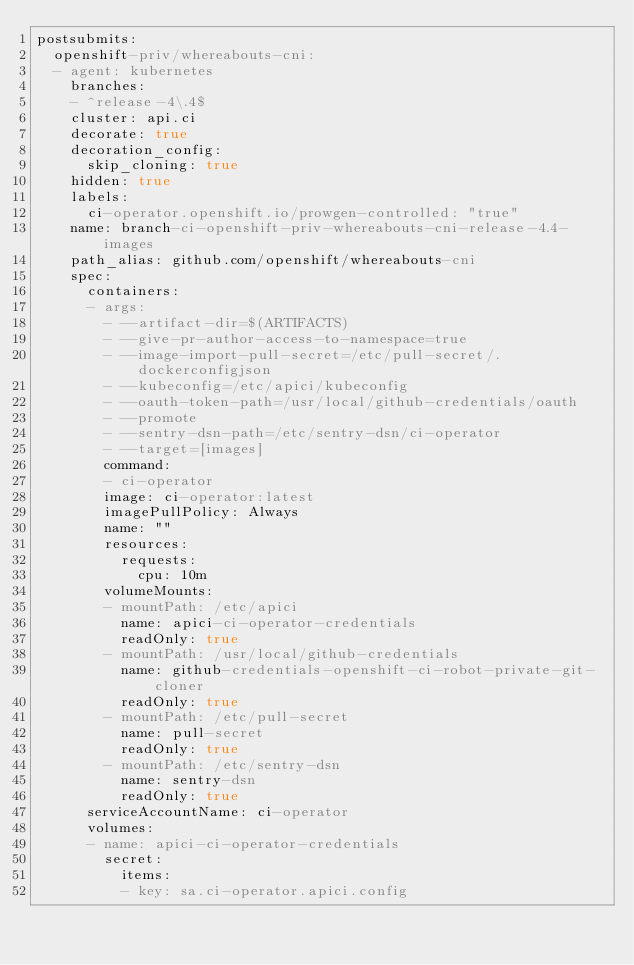Convert code to text. <code><loc_0><loc_0><loc_500><loc_500><_YAML_>postsubmits:
  openshift-priv/whereabouts-cni:
  - agent: kubernetes
    branches:
    - ^release-4\.4$
    cluster: api.ci
    decorate: true
    decoration_config:
      skip_cloning: true
    hidden: true
    labels:
      ci-operator.openshift.io/prowgen-controlled: "true"
    name: branch-ci-openshift-priv-whereabouts-cni-release-4.4-images
    path_alias: github.com/openshift/whereabouts-cni
    spec:
      containers:
      - args:
        - --artifact-dir=$(ARTIFACTS)
        - --give-pr-author-access-to-namespace=true
        - --image-import-pull-secret=/etc/pull-secret/.dockerconfigjson
        - --kubeconfig=/etc/apici/kubeconfig
        - --oauth-token-path=/usr/local/github-credentials/oauth
        - --promote
        - --sentry-dsn-path=/etc/sentry-dsn/ci-operator
        - --target=[images]
        command:
        - ci-operator
        image: ci-operator:latest
        imagePullPolicy: Always
        name: ""
        resources:
          requests:
            cpu: 10m
        volumeMounts:
        - mountPath: /etc/apici
          name: apici-ci-operator-credentials
          readOnly: true
        - mountPath: /usr/local/github-credentials
          name: github-credentials-openshift-ci-robot-private-git-cloner
          readOnly: true
        - mountPath: /etc/pull-secret
          name: pull-secret
          readOnly: true
        - mountPath: /etc/sentry-dsn
          name: sentry-dsn
          readOnly: true
      serviceAccountName: ci-operator
      volumes:
      - name: apici-ci-operator-credentials
        secret:
          items:
          - key: sa.ci-operator.apici.config</code> 